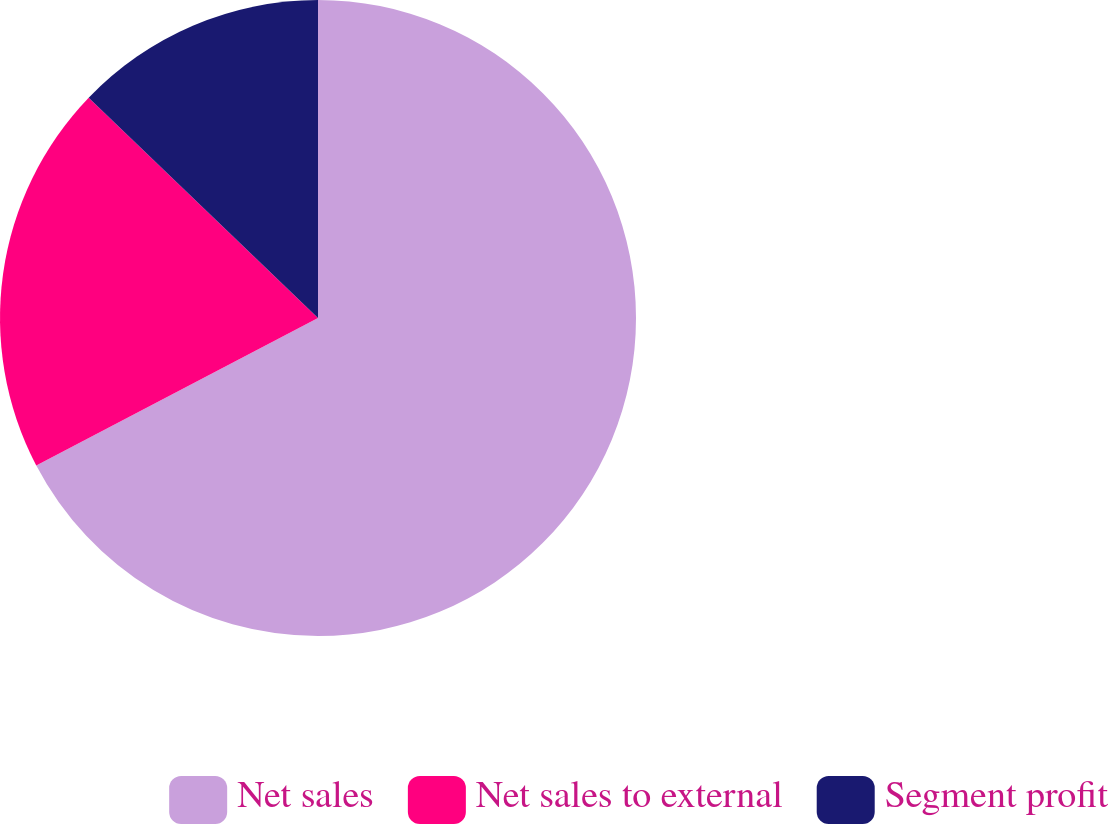Convert chart. <chart><loc_0><loc_0><loc_500><loc_500><pie_chart><fcel>Net sales<fcel>Net sales to external<fcel>Segment profit<nl><fcel>67.33%<fcel>19.86%<fcel>12.82%<nl></chart> 